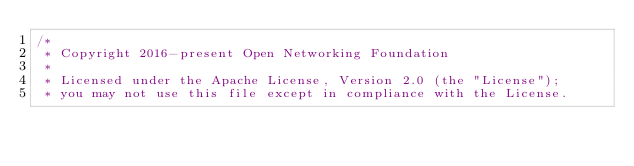<code> <loc_0><loc_0><loc_500><loc_500><_Java_>/*
 * Copyright 2016-present Open Networking Foundation
 *
 * Licensed under the Apache License, Version 2.0 (the "License");
 * you may not use this file except in compliance with the License.</code> 